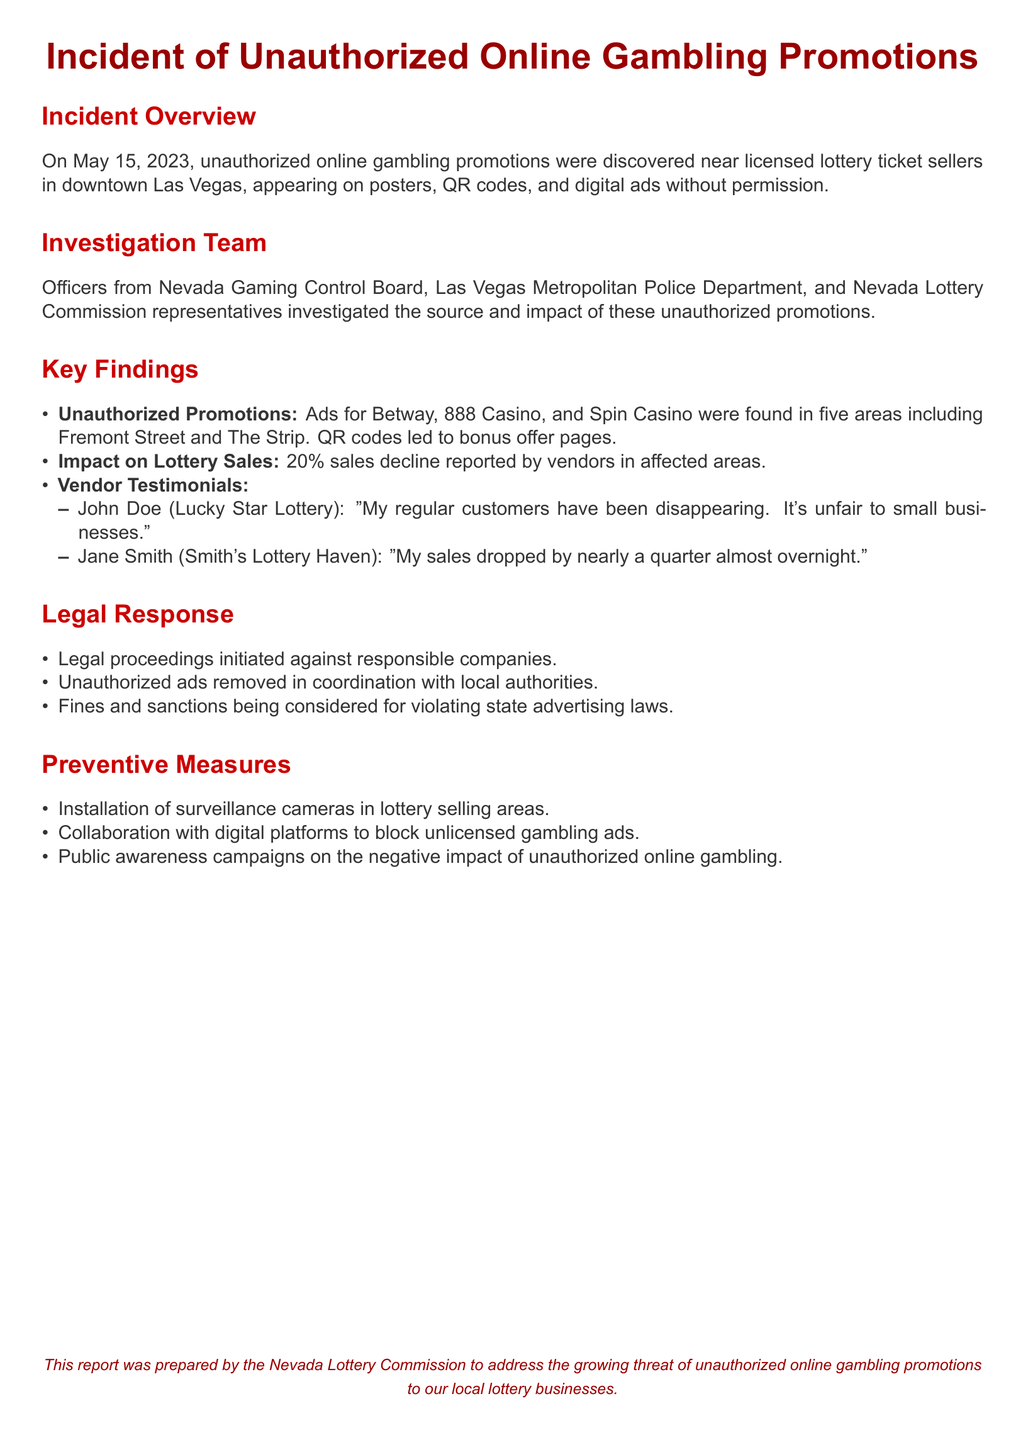what date did the incident occur? The date of the incident is explicitly mentioned in the document as May 15, 2023.
Answer: May 15, 2023 how many areas were affected by the unauthorized promotions? The document specifies that there were five areas where unauthorized promotions were found.
Answer: five what percentage decline in sales was reported by vendors? The document states that there was a 20% sales decline reported by vendors in affected areas.
Answer: 20% which companies were mentioned in relation to unauthorized promotions? The document lists Betway, 888 Casino, and Spin Casino as companies involved in the unauthorized promotions.
Answer: Betway, 888 Casino, Spin Casino what measure is suggested for collaboration with digital platforms? The document mentions collaborating with digital platforms to block unlicensed gambling ads as a preventive measure.
Answer: block unlicensed gambling ads who provided a testimonial about sales decline? The document mentions John Doe from Lucky Star Lottery and Jane Smith from Smith's Lottery Haven as vendors who provided testimonials.
Answer: John Doe, Jane Smith what type of legal action was initiated? The document states that legal proceedings were initiated against the responsible companies for unauthorized promotions.
Answer: legal proceedings what was proposed to increase awareness about unauthorized gambling? The document includes the suggestion of public awareness campaigns on the negative impact of unauthorized online gambling.
Answer: public awareness campaigns what agency prepared the report? The report was prepared by the Nevada Lottery Commission.
Answer: Nevada Lottery Commission 